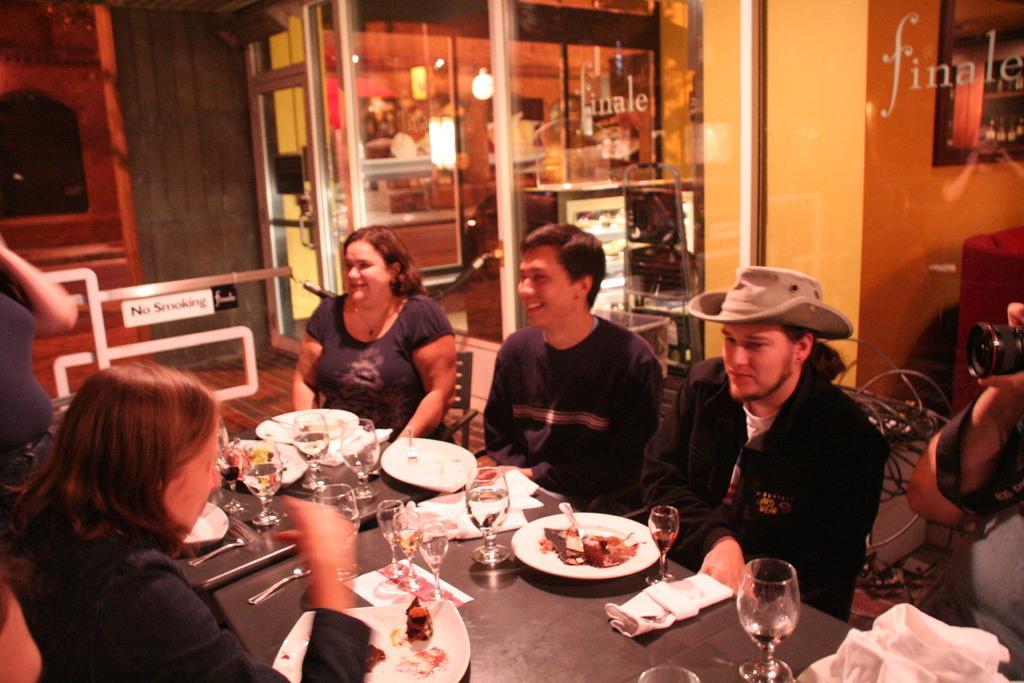Describe this image in one or two sentences. There is a group of people. They are sitting on a chairs. On the right side of the person is holding a camera and another person is wearing a cap. On the left side of the person is standing. There is a table. There is a plate,glass,bottle,fork,spoon,food item and tissue on a table. We can see in the background shop ,glass door and wall. 